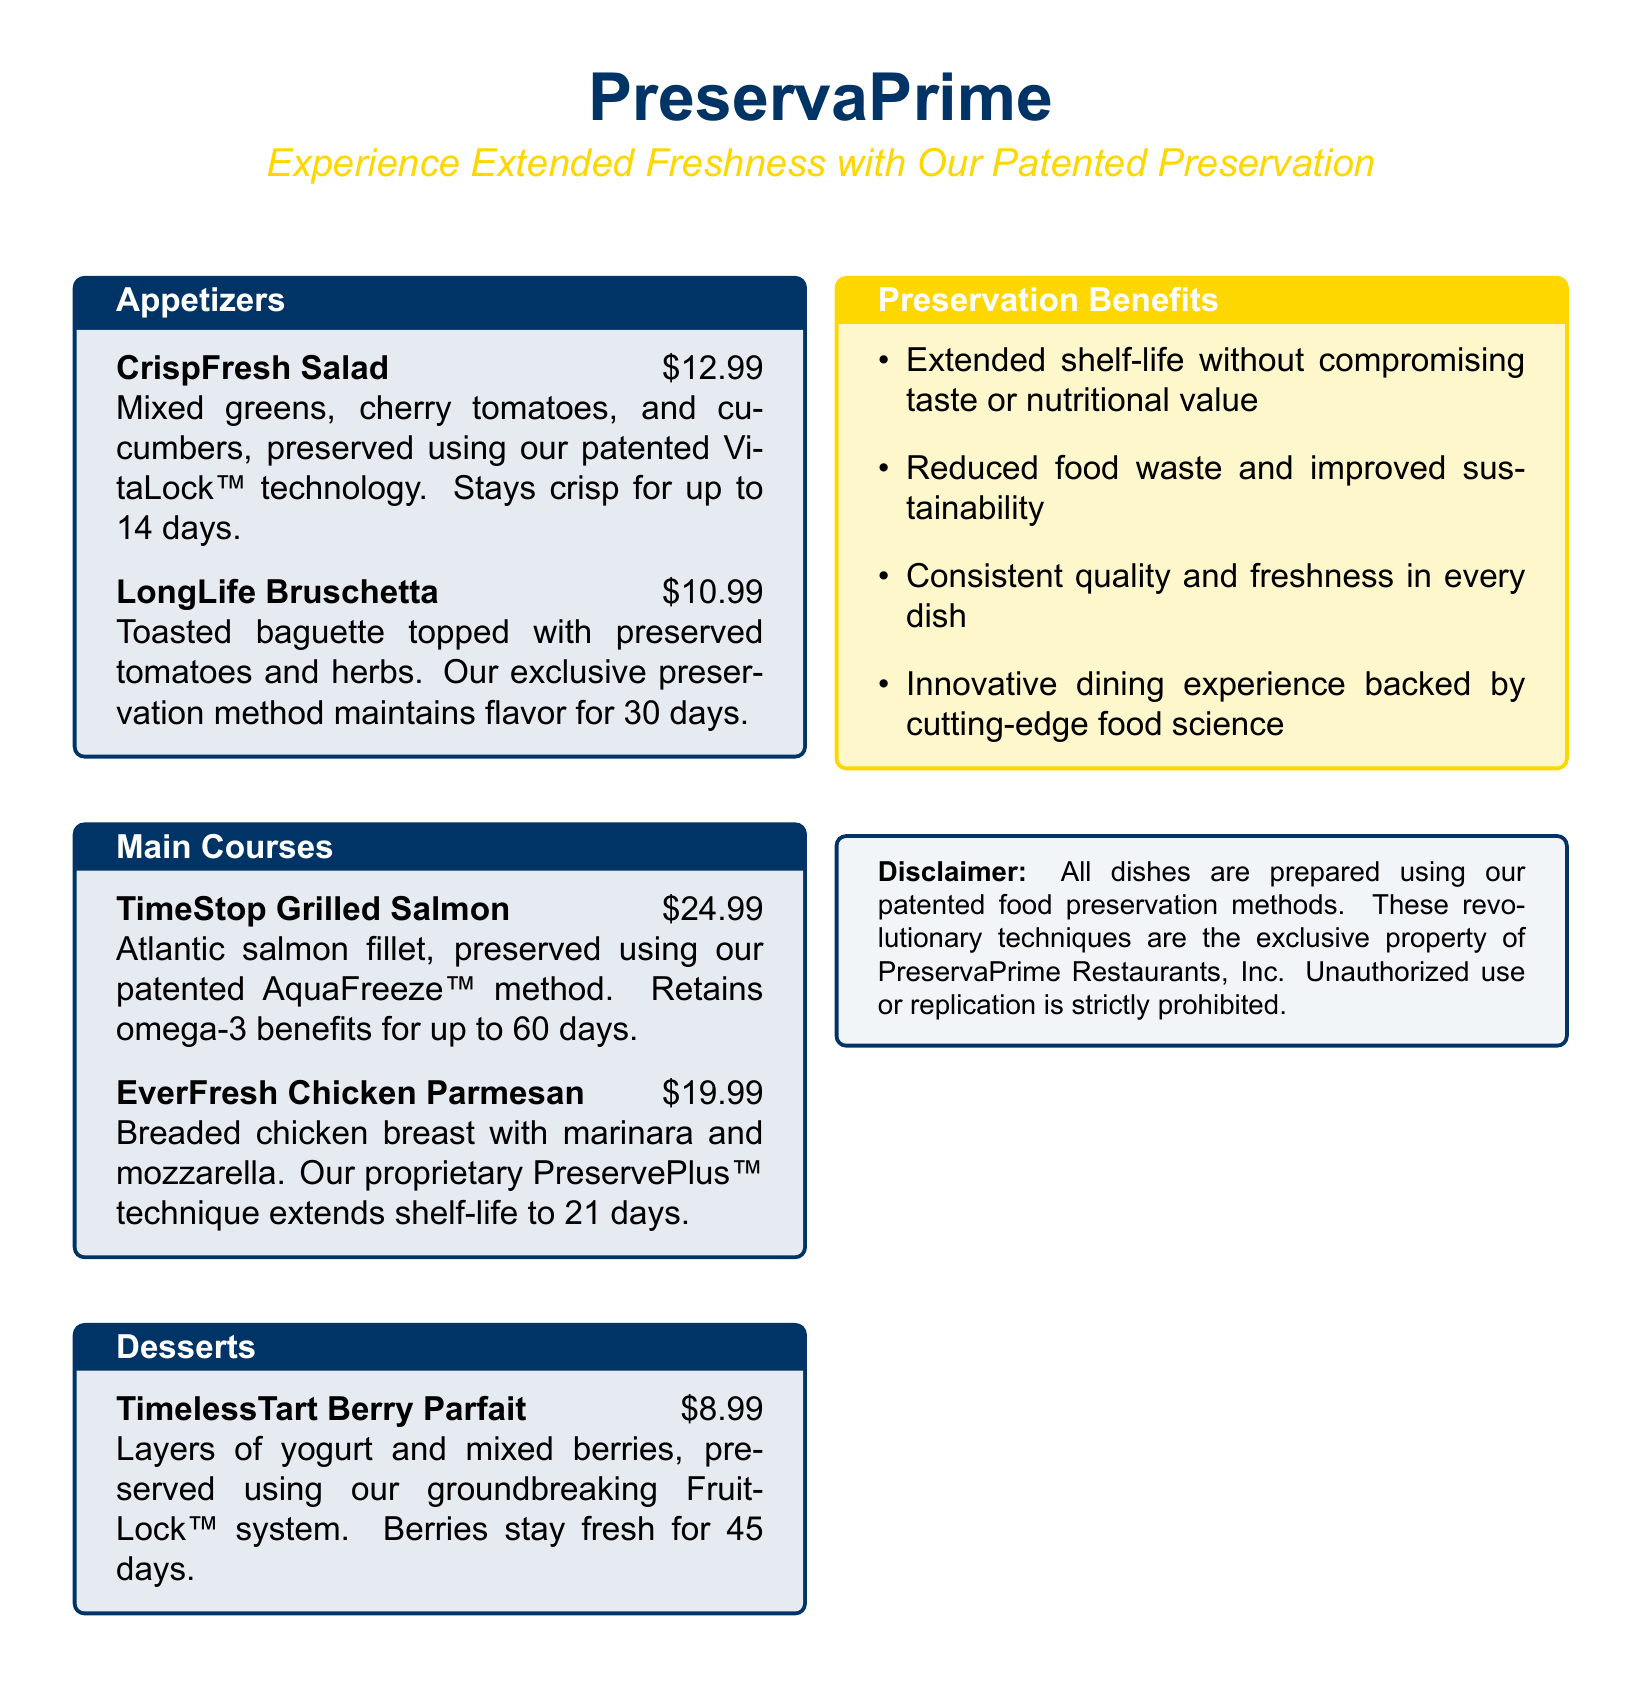What is the price of the CrispFresh Salad? The price is specified as part of the dish description on the menu.
Answer: $12.99 How long do the tomatoes in LongLife Bruschetta stay fresh? The shelf-life stated for the preserved tomatoes is included in the dish description.
Answer: 30 days What is the name of the preservation method used for TimeStop Grilled Salmon? The method is listed under the dish description as a key feature of the salmon preparation.
Answer: AquaFreeze™ How many layers are in the TimelessTart Berry Parfait? The description suggests the composition of the dish, indicating multiple layers.
Answer: Layers What is the extended shelf-life of the EverFresh Chicken Parmesan? The shelf-life is highlighted in the dish description and is a key aspect of the meal.
Answer: 21 days Which patented technology is mentioned for preserving mixed berries? The technology is explicitly stated in the dessert description.
Answer: FruitLock™ What is the main nutritional benefit retained by the TimeStop Grilled Salmon? The description emphasizes a specific nutrient that remains after preservation.
Answer: Omega-3 What is the overarching theme of the PreservaPrime menu? The theme reflects the unique selling point highlighted throughout the menu.
Answer: Extended Freshness How many benefits of preservation are listed in the document? The number of listed benefits is explicitly stated in the preservation benefits section.
Answer: Four 